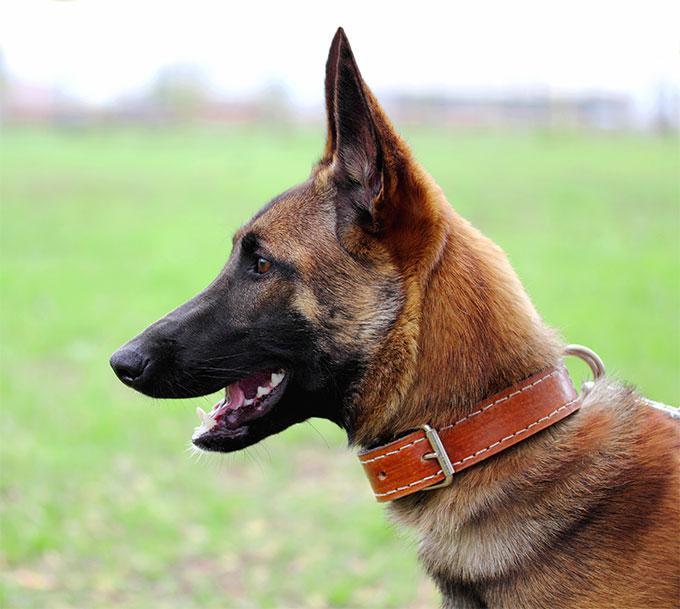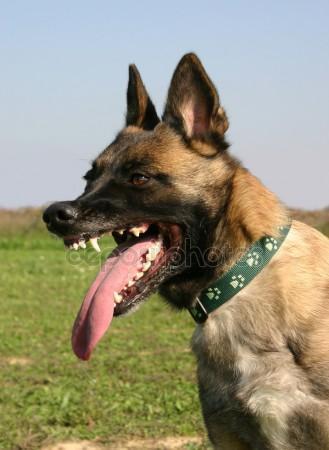The first image is the image on the left, the second image is the image on the right. Evaluate the accuracy of this statement regarding the images: "At least one animal has no visible collar or leash.". Is it true? Answer yes or no. No. 